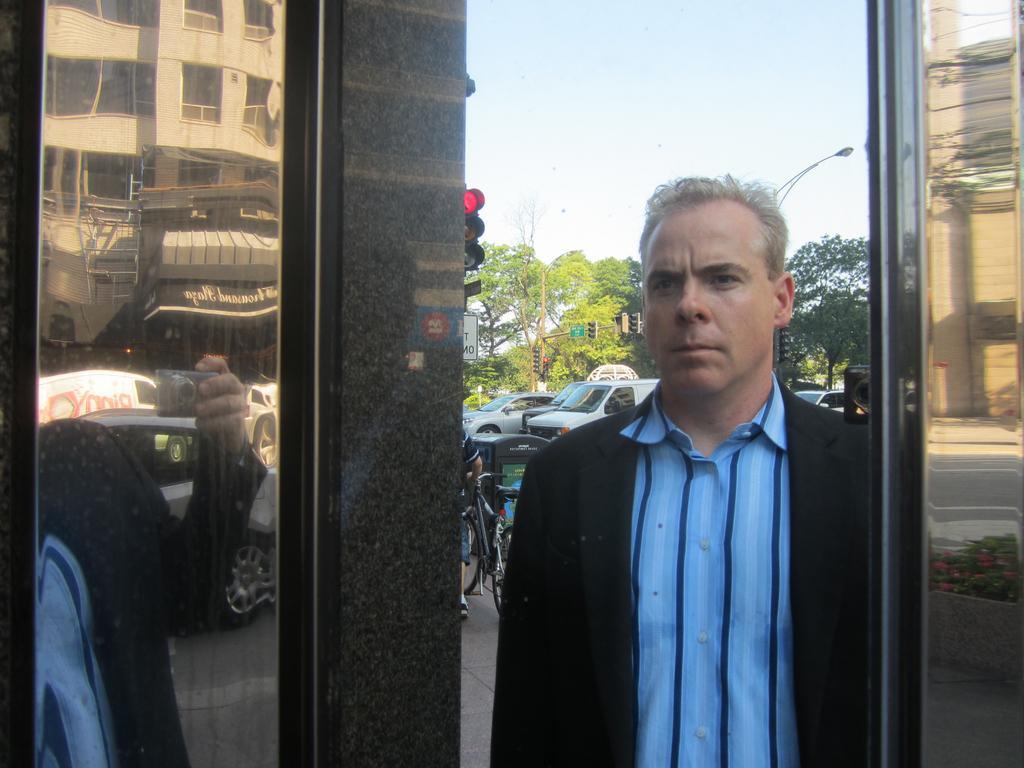Please provide a concise description of this image. In this image I can see a person wearing black and blue colored dress is stunning. In the background I can see few vehicles on the road, a traffic signal, few trees which are green in color and the sky. To the left side of the image I can see the reflection of few a person, few vehicles and a building. 